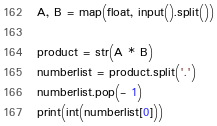<code> <loc_0><loc_0><loc_500><loc_500><_Python_>A, B = map(float, input().split())

product = str(A * B)
numberlist = product.split('.')
numberlist.pop(- 1)
print(int(numberlist[0]))</code> 